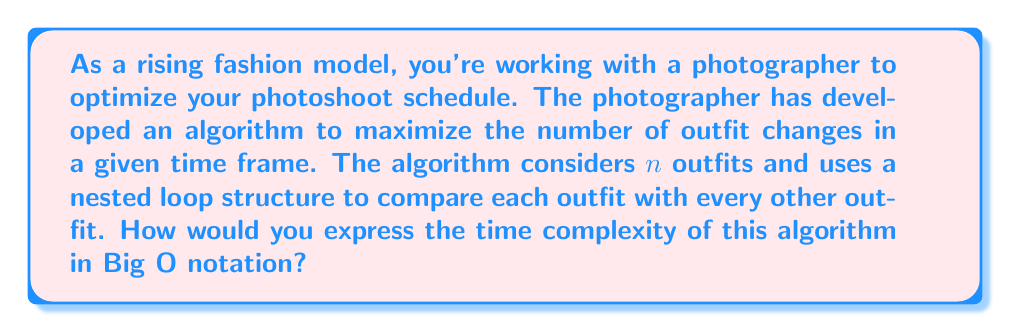Teach me how to tackle this problem. Let's break this down step-by-step:

1) The algorithm is comparing each outfit with every other outfit. This suggests a nested loop structure.

2) The outer loop will iterate through all $n$ outfits.

3) For each outfit in the outer loop, the inner loop will compare it with every other outfit. However, it doesn't need to compare an outfit with itself or repeat comparisons, so it will make $(n-1)$ comparisons in the first iteration, $(n-2)$ in the second, and so on.

4) The total number of comparisons can be represented as:

   $$(n-1) + (n-2) + (n-3) + ... + 2 + 1$$

5) This is the sum of the first $(n-1)$ natural numbers, which has a well-known formula:

   $$\frac{n(n-1)}{2}$$

6) In terms of growth rate, the $\frac{1}{2}$ factor and the $-1$ term become insignificant for large $n$. 

7) Therefore, the dominant term is $n^2$.

8) In Big O notation, we express this as $O(n^2)$.

This quadratic time complexity means that as the number of outfits increases, the time taken by the algorithm increases quadratically. For a fashion model dealing with numerous outfit changes, this could become time-consuming for large photoshoots.
Answer: $O(n^2)$ 